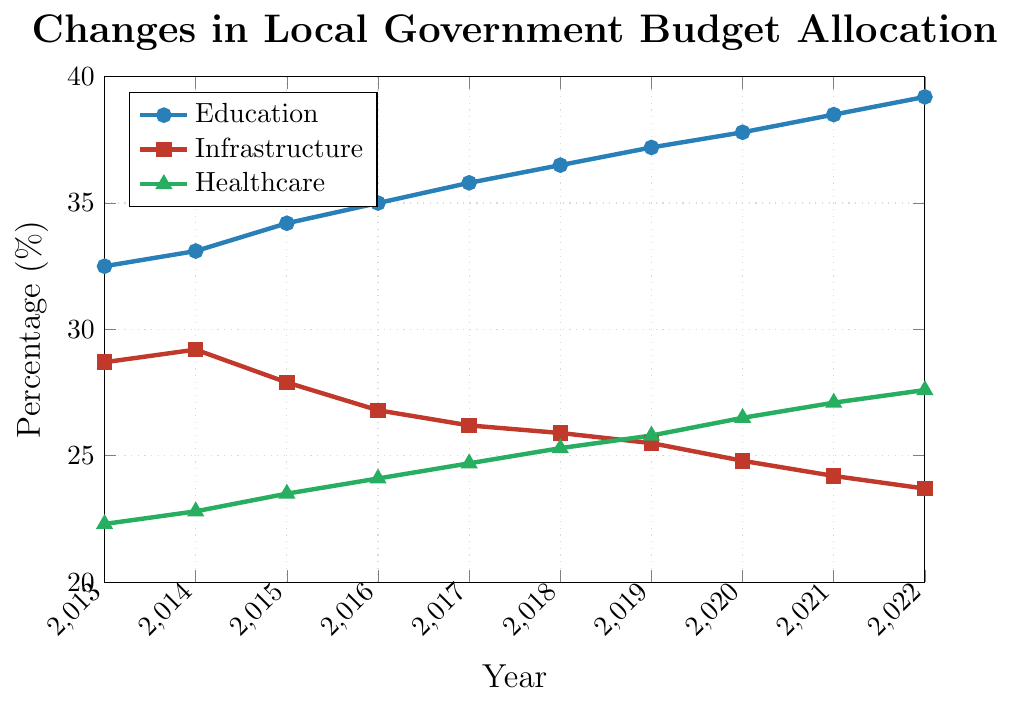What trend do you observe in the budget allocation for Education over the last decade? The budget allocation for Education shows a steady increase from 32.5% in 2013 to 39.2% in 2022. Each year, the percentage grows incrementally without any dips.
Answer: Steady increase How does the budget allocation for Infrastructure in 2022 compare to the allocation in 2013? The budget allocation for Infrastructure decreased from 28.7% in 2013 to 23.7% in 2022. This reveals a downward trend over the decade.
Answer: Decreased Which sector saw the highest increase in budget allocation over the last decade? To determine this, we compare the increase in percentages for each sector from 2013 to 2022. Education increased from 32.5% to 39.2% (a 6.7% increase), Healthcare from 22.3% to 27.6% (a 5.3% increase), and Infrastructure decreased from 28.7% to 23.7% (a 5% decrease). Hence, Education saw the highest increase.
Answer: Education By how much did the healthcare budget allocation change from 2018 to 2022? The percentage for Healthcare in 2018 was 25.3%, and in 2022 it was 27.6%. The change is calculated as 27.6% - 25.3% = 2.3%.
Answer: 2.3% Which year did the Education sector see the most significant increase in budget allocation? Reviewing the data year by year, Education had a consistent increase, but the largest jump is from 2021 (38.5%) to 2022 (39.2%). This jump is 0.7%.
Answer: 2021-2022 In 2017, what was the difference in budget allocations between Education and Infrastructure? The budget allocation for Education in 2017 was 35.8%, while for Infrastructure it was 26.2%. The difference is calculated as 35.8% - 26.2% = 9.6%.
Answer: 9.6% Which sector consistently received the lowest budget allocation over the years? From 2013 to 2022, the Healthcare sector consistently received the lowest percentage of budget allocation each year in comparison with Education and Infrastructure.
Answer: Healthcare What was the average budget allocation for the Infrastructure sector over the decade? Sum up the Infrastructure allocations: 28.7 + 29.2 + 27.9 + 26.8 + 26.2 + 25.9 + 25.5 + 24.8 + 24.2 + 23.7 = 263.9. Average is 263.9 / 10 = 26.39%.
Answer: 26.39% By how much did the budget allocation for Healthcare increase between 2020 and 2021? In 2020, Healthcare had an allocation of 26.5%, and in 2021 it increased to 27.1%. The increase is 27.1% - 26.5% = 0.6%.
Answer: 0.6% Between which years did Infrastructure see the largest annual decrease in budget allocation? By examining the annual changes: 
2014-2015 (29.2 to 27.9: 1.3% decrease), 
2015-2016 (27.9 to 26.8: 1.1% decrease),
2016-2017 (26.8 to 26.2: 0.6% decrease),
2017-2018 (26.2 to 25.9: 0.3% decrease),
2018-2019 (25.9 to 25.5: 0.4% decrease),
2019-2020 (25.5 to 24.8: 0.7% decrease),
2020-2021 (24.8 to 24.2: 0.6% decrease),
2021-2022 (24.2 to 23.7: 0.5% decrease).
The largest annual decrease is between 2014 and 2015 with a 1.3% decrease.
Answer: 2014-2015 